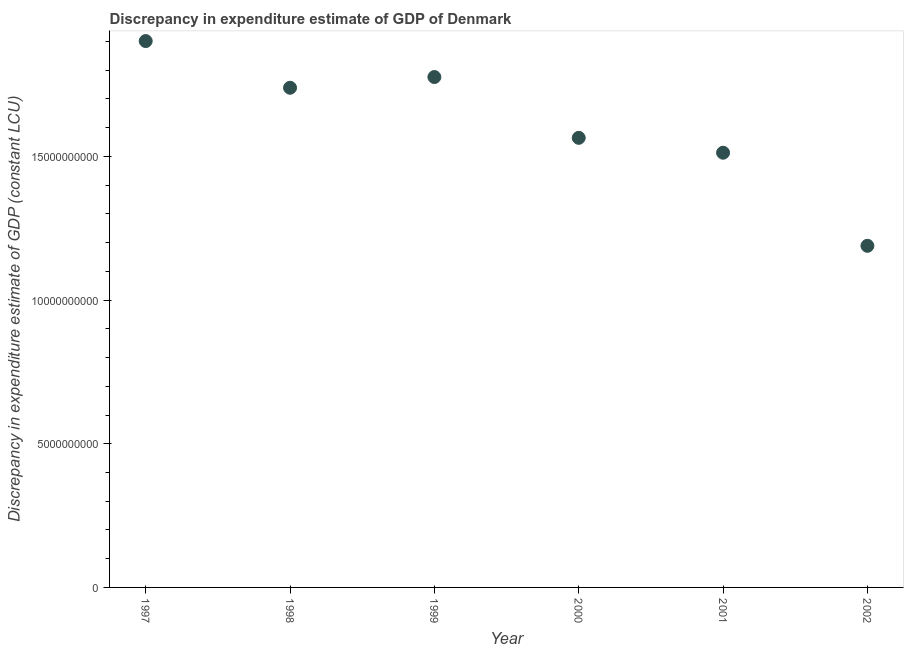What is the discrepancy in expenditure estimate of gdp in 1997?
Offer a terse response. 1.90e+1. Across all years, what is the maximum discrepancy in expenditure estimate of gdp?
Keep it short and to the point. 1.90e+1. Across all years, what is the minimum discrepancy in expenditure estimate of gdp?
Offer a terse response. 1.19e+1. In which year was the discrepancy in expenditure estimate of gdp maximum?
Ensure brevity in your answer.  1997. In which year was the discrepancy in expenditure estimate of gdp minimum?
Make the answer very short. 2002. What is the sum of the discrepancy in expenditure estimate of gdp?
Offer a very short reply. 9.68e+1. What is the difference between the discrepancy in expenditure estimate of gdp in 1998 and 2002?
Offer a terse response. 5.50e+09. What is the average discrepancy in expenditure estimate of gdp per year?
Offer a terse response. 1.61e+1. What is the median discrepancy in expenditure estimate of gdp?
Your response must be concise. 1.65e+1. In how many years, is the discrepancy in expenditure estimate of gdp greater than 16000000000 LCU?
Offer a very short reply. 3. Do a majority of the years between 2001 and 1998 (inclusive) have discrepancy in expenditure estimate of gdp greater than 6000000000 LCU?
Keep it short and to the point. Yes. What is the ratio of the discrepancy in expenditure estimate of gdp in 1997 to that in 1999?
Give a very brief answer. 1.07. What is the difference between the highest and the second highest discrepancy in expenditure estimate of gdp?
Your response must be concise. 1.25e+09. What is the difference between the highest and the lowest discrepancy in expenditure estimate of gdp?
Your response must be concise. 7.13e+09. In how many years, is the discrepancy in expenditure estimate of gdp greater than the average discrepancy in expenditure estimate of gdp taken over all years?
Give a very brief answer. 3. How many years are there in the graph?
Give a very brief answer. 6. Are the values on the major ticks of Y-axis written in scientific E-notation?
Offer a terse response. No. Does the graph contain any zero values?
Provide a short and direct response. No. What is the title of the graph?
Your response must be concise. Discrepancy in expenditure estimate of GDP of Denmark. What is the label or title of the Y-axis?
Offer a very short reply. Discrepancy in expenditure estimate of GDP (constant LCU). What is the Discrepancy in expenditure estimate of GDP (constant LCU) in 1997?
Your answer should be compact. 1.90e+1. What is the Discrepancy in expenditure estimate of GDP (constant LCU) in 1998?
Keep it short and to the point. 1.74e+1. What is the Discrepancy in expenditure estimate of GDP (constant LCU) in 1999?
Ensure brevity in your answer.  1.78e+1. What is the Discrepancy in expenditure estimate of GDP (constant LCU) in 2000?
Provide a succinct answer. 1.56e+1. What is the Discrepancy in expenditure estimate of GDP (constant LCU) in 2001?
Keep it short and to the point. 1.51e+1. What is the Discrepancy in expenditure estimate of GDP (constant LCU) in 2002?
Give a very brief answer. 1.19e+1. What is the difference between the Discrepancy in expenditure estimate of GDP (constant LCU) in 1997 and 1998?
Provide a succinct answer. 1.62e+09. What is the difference between the Discrepancy in expenditure estimate of GDP (constant LCU) in 1997 and 1999?
Make the answer very short. 1.25e+09. What is the difference between the Discrepancy in expenditure estimate of GDP (constant LCU) in 1997 and 2000?
Offer a terse response. 3.37e+09. What is the difference between the Discrepancy in expenditure estimate of GDP (constant LCU) in 1997 and 2001?
Give a very brief answer. 3.89e+09. What is the difference between the Discrepancy in expenditure estimate of GDP (constant LCU) in 1997 and 2002?
Offer a very short reply. 7.13e+09. What is the difference between the Discrepancy in expenditure estimate of GDP (constant LCU) in 1998 and 1999?
Give a very brief answer. -3.73e+08. What is the difference between the Discrepancy in expenditure estimate of GDP (constant LCU) in 1998 and 2000?
Ensure brevity in your answer.  1.74e+09. What is the difference between the Discrepancy in expenditure estimate of GDP (constant LCU) in 1998 and 2001?
Keep it short and to the point. 2.26e+09. What is the difference between the Discrepancy in expenditure estimate of GDP (constant LCU) in 1998 and 2002?
Keep it short and to the point. 5.50e+09. What is the difference between the Discrepancy in expenditure estimate of GDP (constant LCU) in 1999 and 2000?
Give a very brief answer. 2.12e+09. What is the difference between the Discrepancy in expenditure estimate of GDP (constant LCU) in 1999 and 2001?
Offer a very short reply. 2.63e+09. What is the difference between the Discrepancy in expenditure estimate of GDP (constant LCU) in 1999 and 2002?
Make the answer very short. 5.87e+09. What is the difference between the Discrepancy in expenditure estimate of GDP (constant LCU) in 2000 and 2001?
Offer a terse response. 5.18e+08. What is the difference between the Discrepancy in expenditure estimate of GDP (constant LCU) in 2000 and 2002?
Provide a succinct answer. 3.76e+09. What is the difference between the Discrepancy in expenditure estimate of GDP (constant LCU) in 2001 and 2002?
Offer a terse response. 3.24e+09. What is the ratio of the Discrepancy in expenditure estimate of GDP (constant LCU) in 1997 to that in 1998?
Ensure brevity in your answer.  1.09. What is the ratio of the Discrepancy in expenditure estimate of GDP (constant LCU) in 1997 to that in 1999?
Offer a terse response. 1.07. What is the ratio of the Discrepancy in expenditure estimate of GDP (constant LCU) in 1997 to that in 2000?
Provide a short and direct response. 1.22. What is the ratio of the Discrepancy in expenditure estimate of GDP (constant LCU) in 1997 to that in 2001?
Offer a very short reply. 1.26. What is the ratio of the Discrepancy in expenditure estimate of GDP (constant LCU) in 1997 to that in 2002?
Offer a terse response. 1.6. What is the ratio of the Discrepancy in expenditure estimate of GDP (constant LCU) in 1998 to that in 2000?
Your answer should be very brief. 1.11. What is the ratio of the Discrepancy in expenditure estimate of GDP (constant LCU) in 1998 to that in 2001?
Ensure brevity in your answer.  1.15. What is the ratio of the Discrepancy in expenditure estimate of GDP (constant LCU) in 1998 to that in 2002?
Provide a succinct answer. 1.46. What is the ratio of the Discrepancy in expenditure estimate of GDP (constant LCU) in 1999 to that in 2000?
Offer a terse response. 1.14. What is the ratio of the Discrepancy in expenditure estimate of GDP (constant LCU) in 1999 to that in 2001?
Make the answer very short. 1.17. What is the ratio of the Discrepancy in expenditure estimate of GDP (constant LCU) in 1999 to that in 2002?
Your response must be concise. 1.49. What is the ratio of the Discrepancy in expenditure estimate of GDP (constant LCU) in 2000 to that in 2001?
Keep it short and to the point. 1.03. What is the ratio of the Discrepancy in expenditure estimate of GDP (constant LCU) in 2000 to that in 2002?
Your response must be concise. 1.32. What is the ratio of the Discrepancy in expenditure estimate of GDP (constant LCU) in 2001 to that in 2002?
Keep it short and to the point. 1.27. 